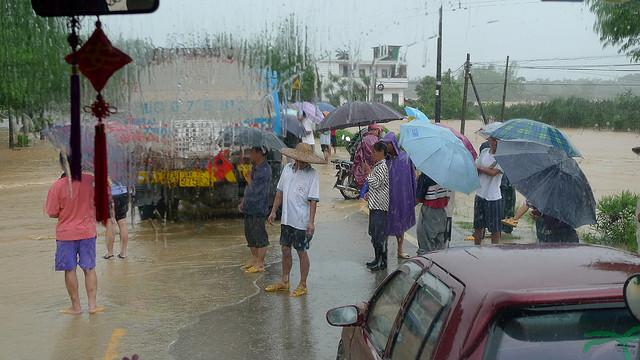What are the people holding the umbrellas trying to avoid? Please explain your reasoning. rain. There is water falling from the sky, and most people don't want to be wet. 